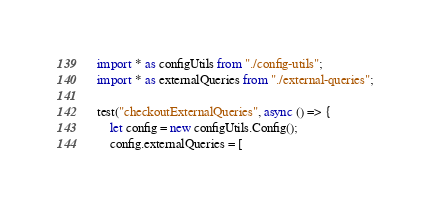<code> <loc_0><loc_0><loc_500><loc_500><_TypeScript_>
import * as configUtils from "./config-utils";
import * as externalQueries from "./external-queries";

test("checkoutExternalQueries", async () => {
    let config = new configUtils.Config();
    config.externalQueries = [</code> 